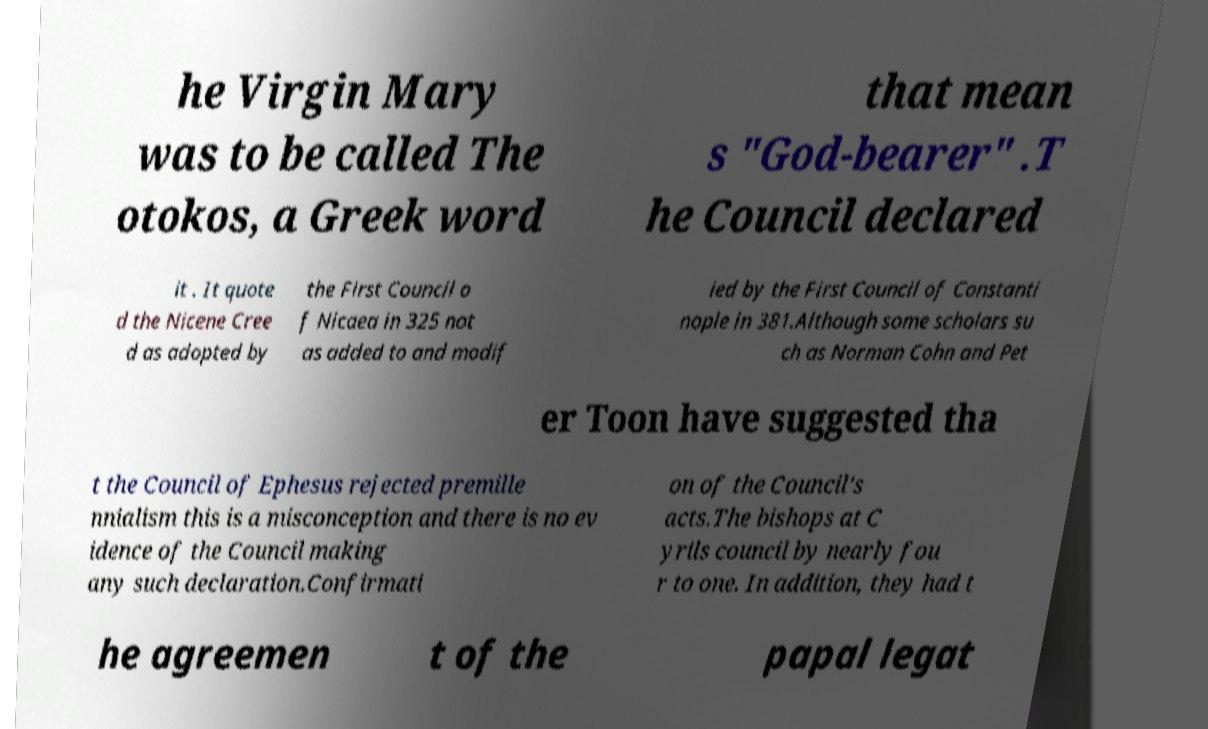There's text embedded in this image that I need extracted. Can you transcribe it verbatim? he Virgin Mary was to be called The otokos, a Greek word that mean s "God-bearer" .T he Council declared it . It quote d the Nicene Cree d as adopted by the First Council o f Nicaea in 325 not as added to and modif ied by the First Council of Constanti nople in 381.Although some scholars su ch as Norman Cohn and Pet er Toon have suggested tha t the Council of Ephesus rejected premille nnialism this is a misconception and there is no ev idence of the Council making any such declaration.Confirmati on of the Council's acts.The bishops at C yrils council by nearly fou r to one. In addition, they had t he agreemen t of the papal legat 